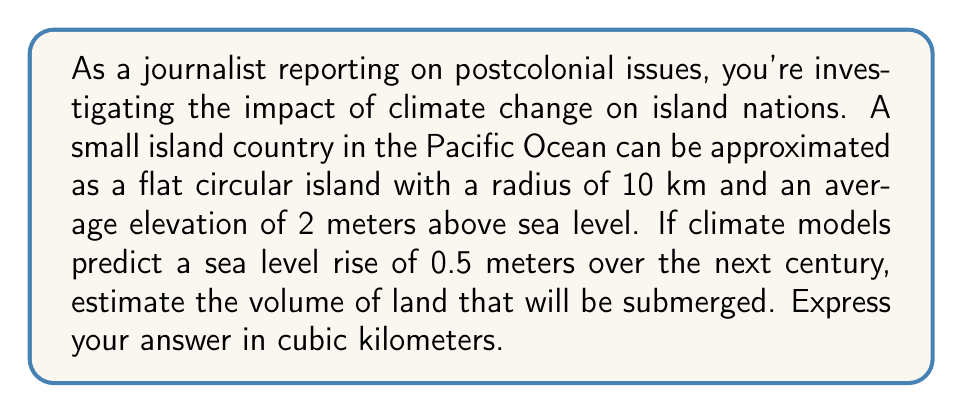Help me with this question. To solve this problem, we need to follow these steps:

1) First, we need to calculate the area of the island. Since it's approximated as a circular island, we use the formula for the area of a circle:

   $A = \pi r^2$

   Where $r$ is the radius of the island (10 km).

2) Calculate the area:

   $A = \pi (10 \text{ km})^2 = 100\pi \text{ km}^2$

3) Now, we need to calculate the volume of water that will displace the land. This can be thought of as a cylinder with the base area equal to the area of the island, and the height equal to the sea level rise.

4) The volume of a cylinder is given by:

   $V = Ah$

   Where $A$ is the base area and $h$ is the height.

5) In this case, $A = 100\pi \text{ km}^2$ and $h = 0.5 \text{ m} = 0.0005 \text{ km}$

6) Calculate the volume:

   $V = 100\pi \text{ km}^2 \cdot 0.0005 \text{ km} = 0.05\pi \text{ km}^3$

7) Simplify:

   $V \approx 0.1571 \text{ km}^3$

This volume represents the amount of land that will be submerged due to the sea level rise.
Answer: Approximately $0.1571 \text{ km}^3$ of land will be submerged. 